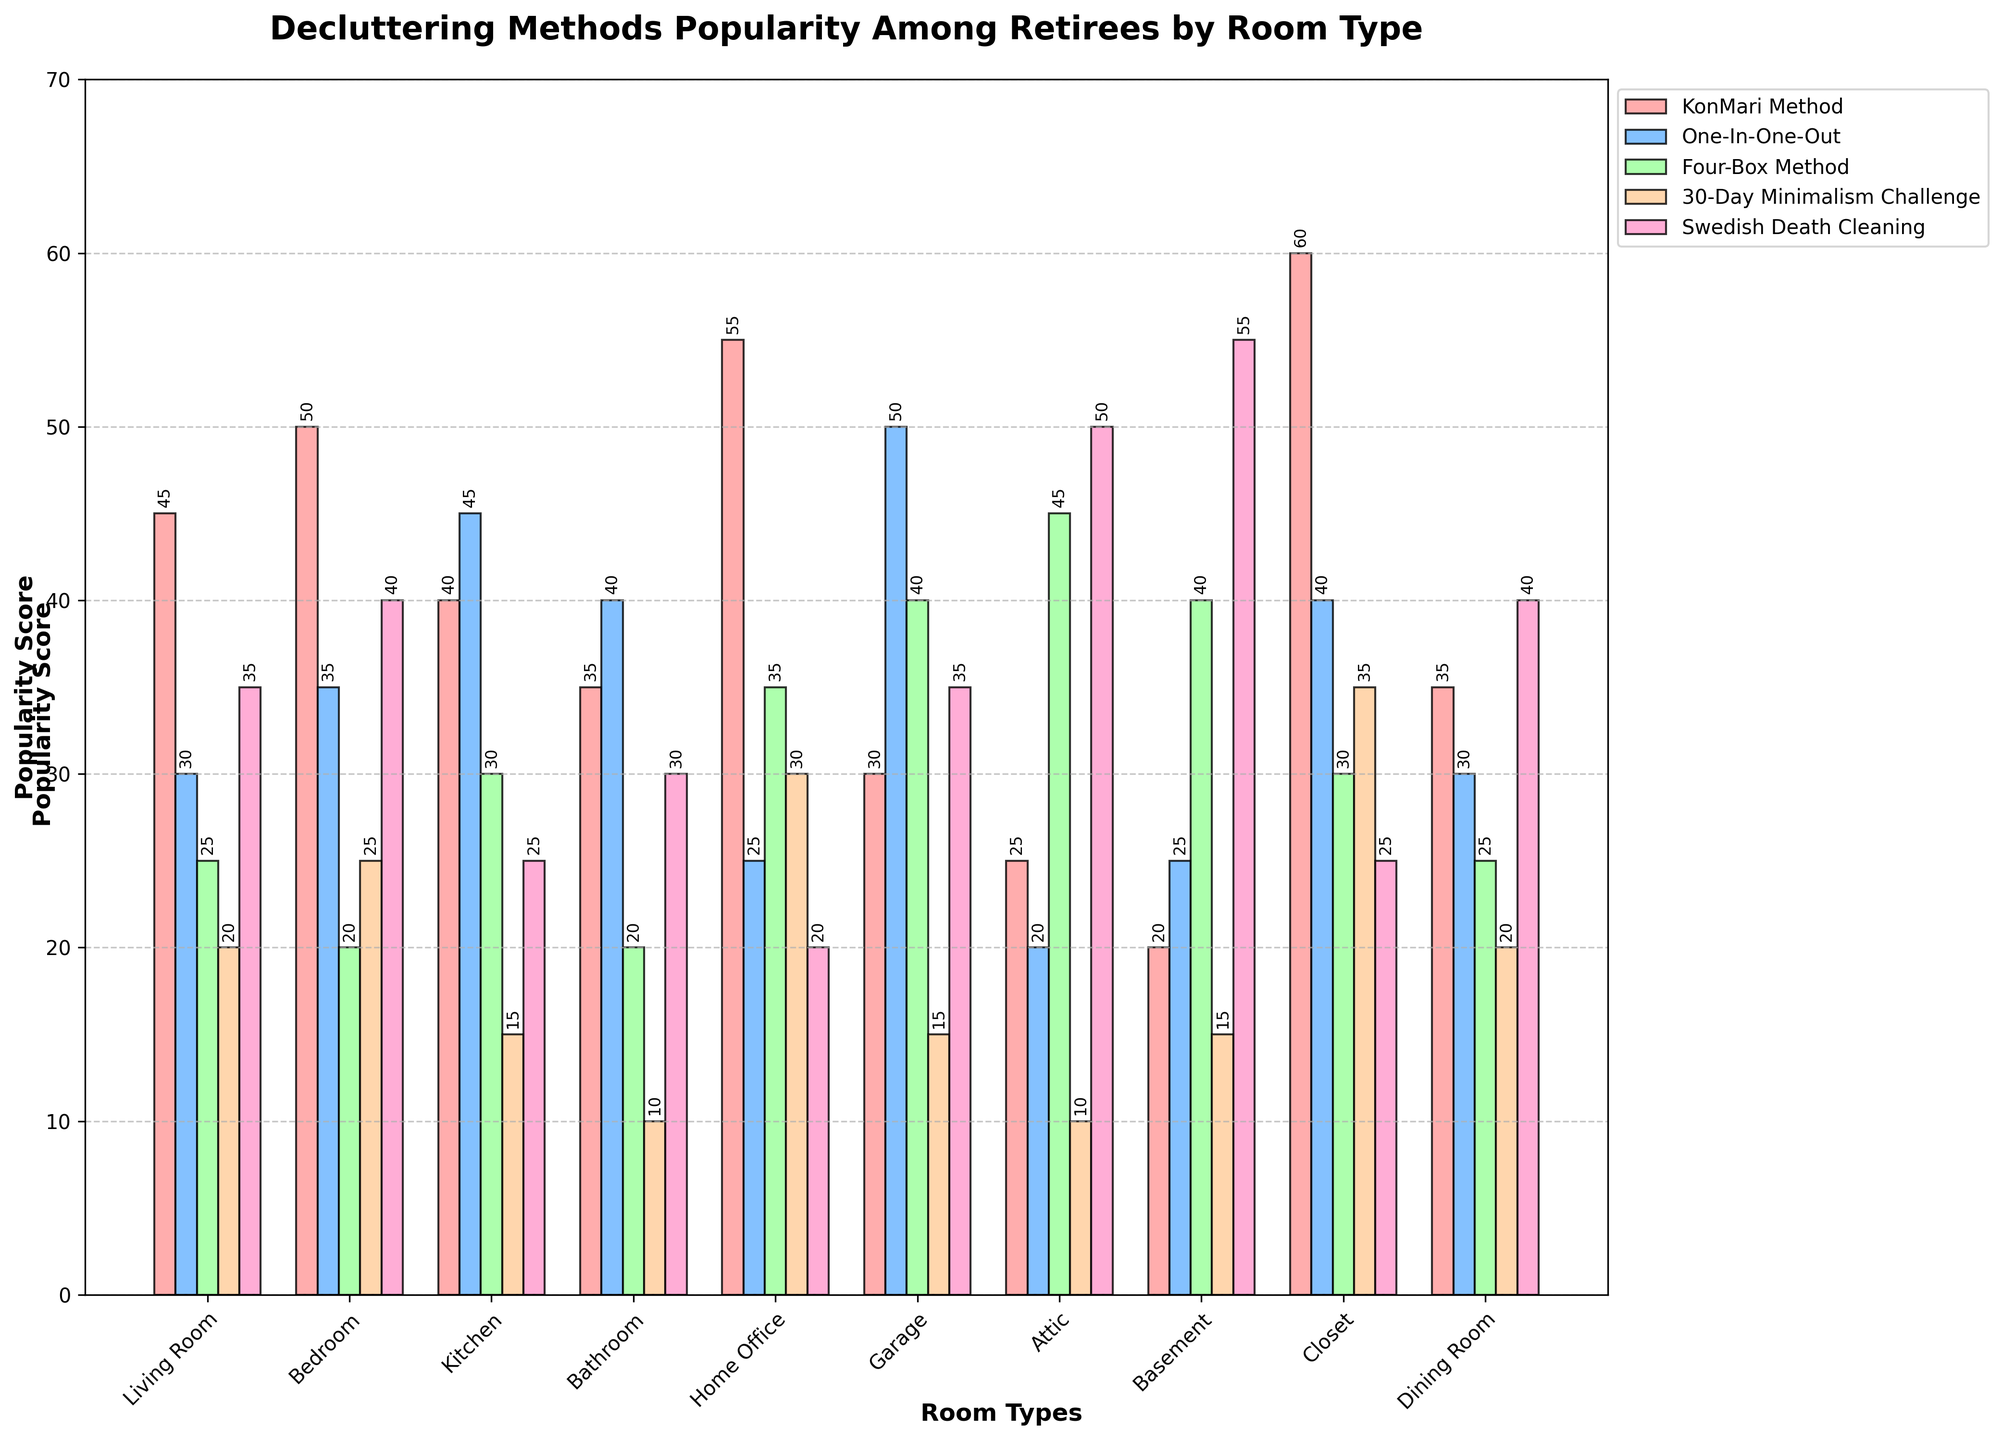Which decluttering method is the most popular in the living room? The KonMari Method has the highest bar in the section labeled Living Room.
Answer: KonMari Method In which room is the 30-Day Minimalism Challenge least popular? In the section labeled Bathroom, the bar for the 30-Day Minimalism Challenge is the shortest.
Answer: Bathroom What is the total popularity score of the One-In-One-Out method across all rooms? Add the values for the One-In-One-Out method in each room: 30 + 35 + 45 + 40 + 25 + 50 + 20 + 25 + 40 + 30. The sum is 340.
Answer: 340 Which room has the highest overall popularity score for the Swedish Death Cleaning method? In the section labeled Basement, the bar for Swedish Death Cleaning method is the highest among all room types.
Answer: Basement Compare the popularity of the KonMari Method and Four-Box Method in the home office. Which one is more popular and by how much? The KonMari Method in the Home Office has a score of 55, and the Four-Box Method has a score of 35. The difference is 55 - 35 = 20.
Answer: KonMari Method by 20 What is the average popularity score of the Swedish Death Cleaning method across all rooms? Add the values for Swedish Death Cleaning method: 35 + 40 + 25 + 30 + 20 + 35 + 50 + 55 + 25 + 40. The sum is 355. Divide by the number of rooms (10): 355 / 10 = 35.5
Answer: 35.5 In which room type is the One-In-One-Out method most popular? In the section labeled Garage, the bar for One-In-One-Out method is the tallest among all room types.
Answer: Garage Which decluttering method has the lowest popularity in the attic? The bar for KonMari Method in the section labeled Attic is the shortest.
Answer: KonMari Method What is the popularity score difference between the KonMari Method and Swedish Death Cleaning in the closet? The KonMari Method in the Closet has a score of 60, and the Swedish Death Cleaning has a score of 25. The difference is 60 - 25 = 35.
Answer: 35 Which room type has an equal popularity score for the Four-Box Method and the 30-Day Minimalism Challenge? The section labeled Living Room shows equal bar heights for both the Four-Box Method and the 30-Day Minimalism Challenge, each with a score of 25.
Answer: Living Room 